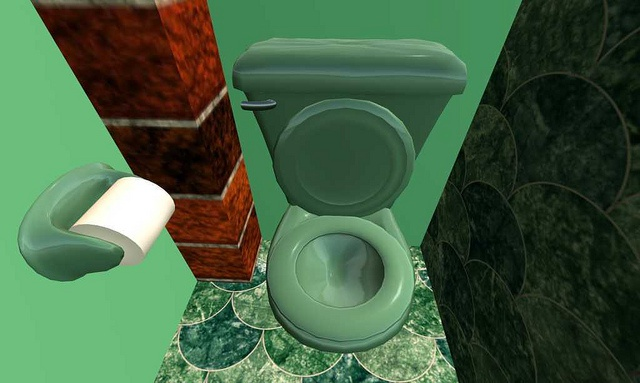Describe the objects in this image and their specific colors. I can see a toilet in lightgreen, darkgreen, green, and teal tones in this image. 